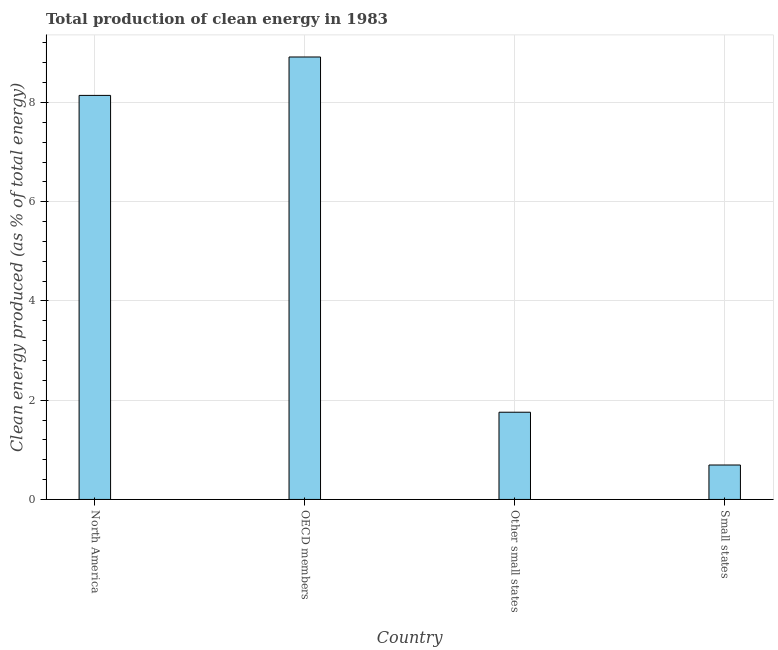Does the graph contain grids?
Give a very brief answer. Yes. What is the title of the graph?
Keep it short and to the point. Total production of clean energy in 1983. What is the label or title of the Y-axis?
Offer a very short reply. Clean energy produced (as % of total energy). What is the production of clean energy in OECD members?
Give a very brief answer. 8.92. Across all countries, what is the maximum production of clean energy?
Make the answer very short. 8.92. Across all countries, what is the minimum production of clean energy?
Offer a terse response. 0.69. In which country was the production of clean energy maximum?
Your answer should be compact. OECD members. In which country was the production of clean energy minimum?
Make the answer very short. Small states. What is the sum of the production of clean energy?
Offer a very short reply. 19.51. What is the difference between the production of clean energy in OECD members and Small states?
Offer a terse response. 8.22. What is the average production of clean energy per country?
Make the answer very short. 4.88. What is the median production of clean energy?
Provide a short and direct response. 4.95. In how many countries, is the production of clean energy greater than 4.4 %?
Ensure brevity in your answer.  2. What is the difference between the highest and the second highest production of clean energy?
Keep it short and to the point. 0.77. Is the sum of the production of clean energy in North America and Small states greater than the maximum production of clean energy across all countries?
Provide a succinct answer. No. What is the difference between the highest and the lowest production of clean energy?
Keep it short and to the point. 8.22. In how many countries, is the production of clean energy greater than the average production of clean energy taken over all countries?
Offer a terse response. 2. How many bars are there?
Provide a short and direct response. 4. Are the values on the major ticks of Y-axis written in scientific E-notation?
Offer a very short reply. No. What is the Clean energy produced (as % of total energy) of North America?
Give a very brief answer. 8.14. What is the Clean energy produced (as % of total energy) in OECD members?
Give a very brief answer. 8.92. What is the Clean energy produced (as % of total energy) in Other small states?
Your answer should be very brief. 1.76. What is the Clean energy produced (as % of total energy) in Small states?
Provide a short and direct response. 0.69. What is the difference between the Clean energy produced (as % of total energy) in North America and OECD members?
Offer a terse response. -0.77. What is the difference between the Clean energy produced (as % of total energy) in North America and Other small states?
Make the answer very short. 6.39. What is the difference between the Clean energy produced (as % of total energy) in North America and Small states?
Your answer should be very brief. 7.45. What is the difference between the Clean energy produced (as % of total energy) in OECD members and Other small states?
Make the answer very short. 7.16. What is the difference between the Clean energy produced (as % of total energy) in OECD members and Small states?
Keep it short and to the point. 8.22. What is the difference between the Clean energy produced (as % of total energy) in Other small states and Small states?
Provide a short and direct response. 1.06. What is the ratio of the Clean energy produced (as % of total energy) in North America to that in OECD members?
Make the answer very short. 0.91. What is the ratio of the Clean energy produced (as % of total energy) in North America to that in Other small states?
Offer a very short reply. 4.63. What is the ratio of the Clean energy produced (as % of total energy) in North America to that in Small states?
Your response must be concise. 11.73. What is the ratio of the Clean energy produced (as % of total energy) in OECD members to that in Other small states?
Your response must be concise. 5.07. What is the ratio of the Clean energy produced (as % of total energy) in OECD members to that in Small states?
Your answer should be very brief. 12.84. What is the ratio of the Clean energy produced (as % of total energy) in Other small states to that in Small states?
Ensure brevity in your answer.  2.53. 